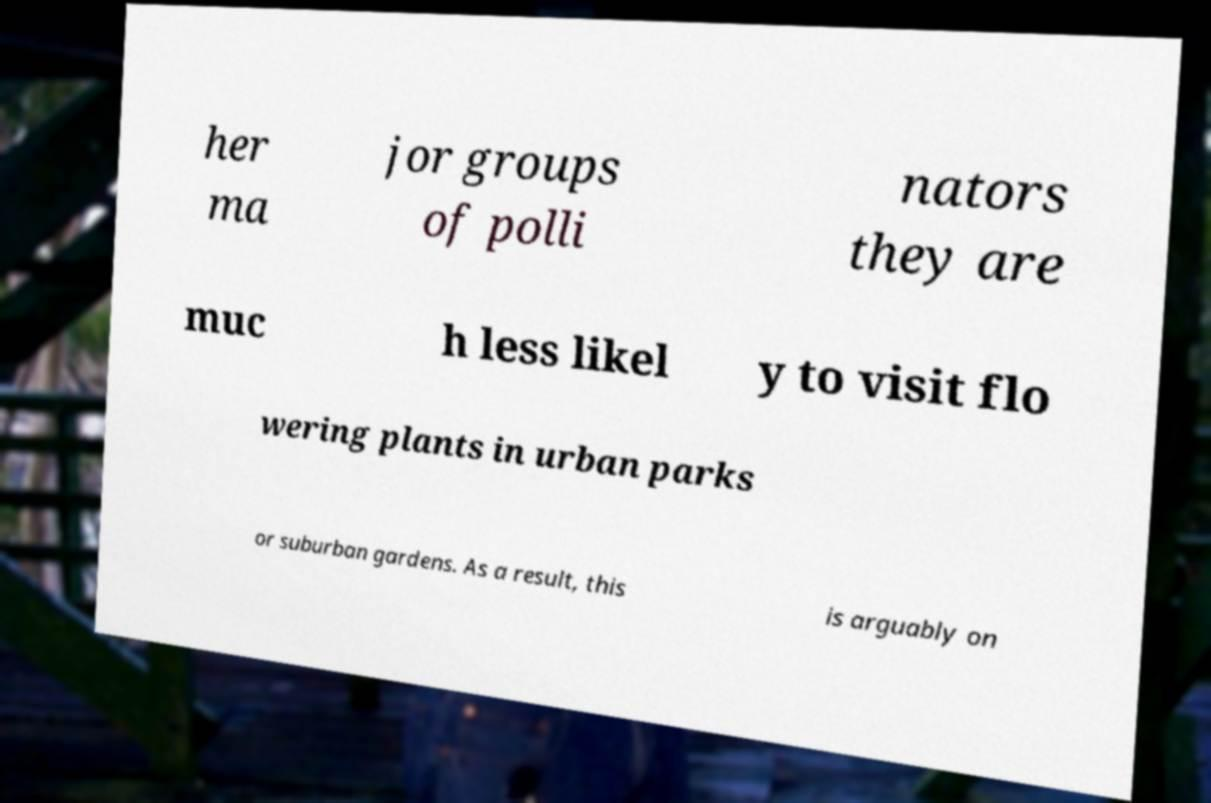For documentation purposes, I need the text within this image transcribed. Could you provide that? her ma jor groups of polli nators they are muc h less likel y to visit flo wering plants in urban parks or suburban gardens. As a result, this is arguably on 